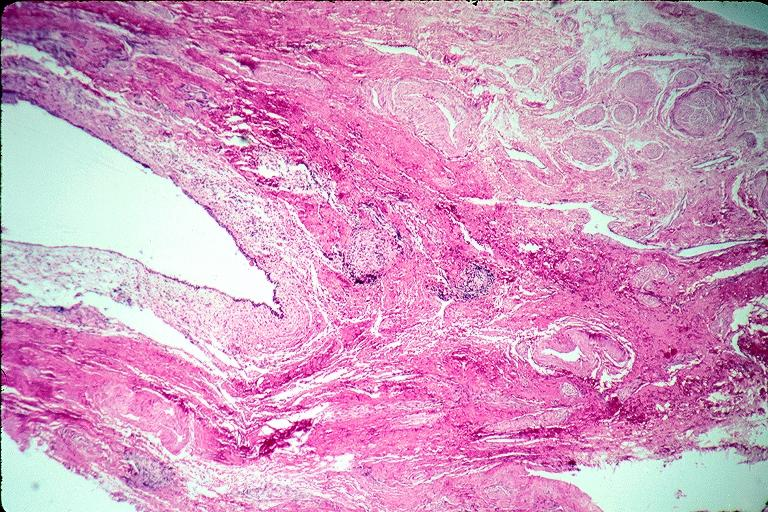s oral present?
Answer the question using a single word or phrase. Yes 